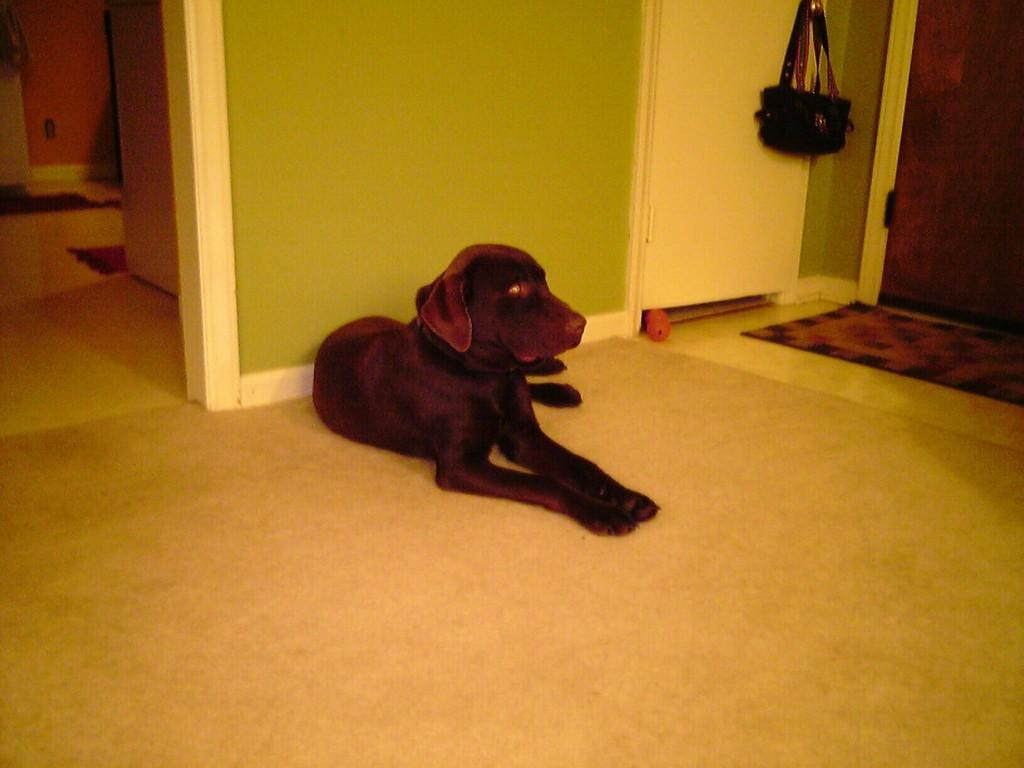What type of animal is in the image? There is a dog in the image. Can you describe the dog's appearance? The dog is brown and black in color. Where is the dog located in the image? The dog is on the floor. What else can be seen near the dog in the image? There is a bag hanging to the right of the dog. What is the setting of the image? The dog is inside a room. What type of plant is hanging from the ceiling in the image? There is no plant hanging from the ceiling in the image; it only features a dog, a bag, and a room. 